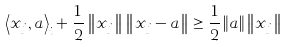<formula> <loc_0><loc_0><loc_500><loc_500>\left \langle x _ { j } , a \right \rangle _ { i } + \frac { 1 } { 2 } \left \| x _ { j } \right \| \left \| x _ { j } - a \right \| \geq \frac { 1 } { 2 } \left \| a \right \| \left \| x _ { j } \right \|</formula> 